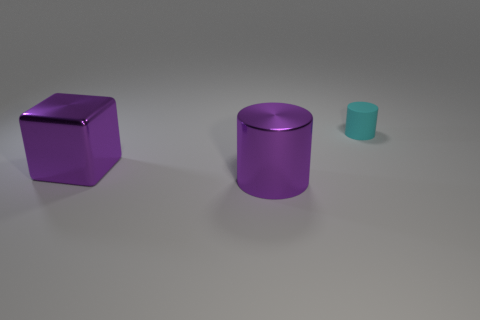Is the metallic cylinder the same color as the large cube?
Ensure brevity in your answer.  Yes. Are there any big metallic objects of the same shape as the rubber object?
Your response must be concise. Yes. There is a thing that is in front of the large purple block; is its color the same as the large block?
Offer a terse response. Yes. The shiny thing that is the same color as the cube is what shape?
Offer a very short reply. Cylinder. What number of objects are objects in front of the cyan matte cylinder or cyan matte things?
Give a very brief answer. 3. What is the color of the shiny cylinder that is the same size as the block?
Provide a short and direct response. Purple. Is the number of large purple cylinders in front of the purple cube greater than the number of big red cylinders?
Make the answer very short. Yes. What is the thing that is on the left side of the cyan cylinder and on the right side of the metallic cube made of?
Make the answer very short. Metal. Do the large metallic object in front of the large purple block and the thing left of the big shiny cylinder have the same color?
Give a very brief answer. Yes. What number of other things are there of the same size as the purple cube?
Provide a short and direct response. 1. 